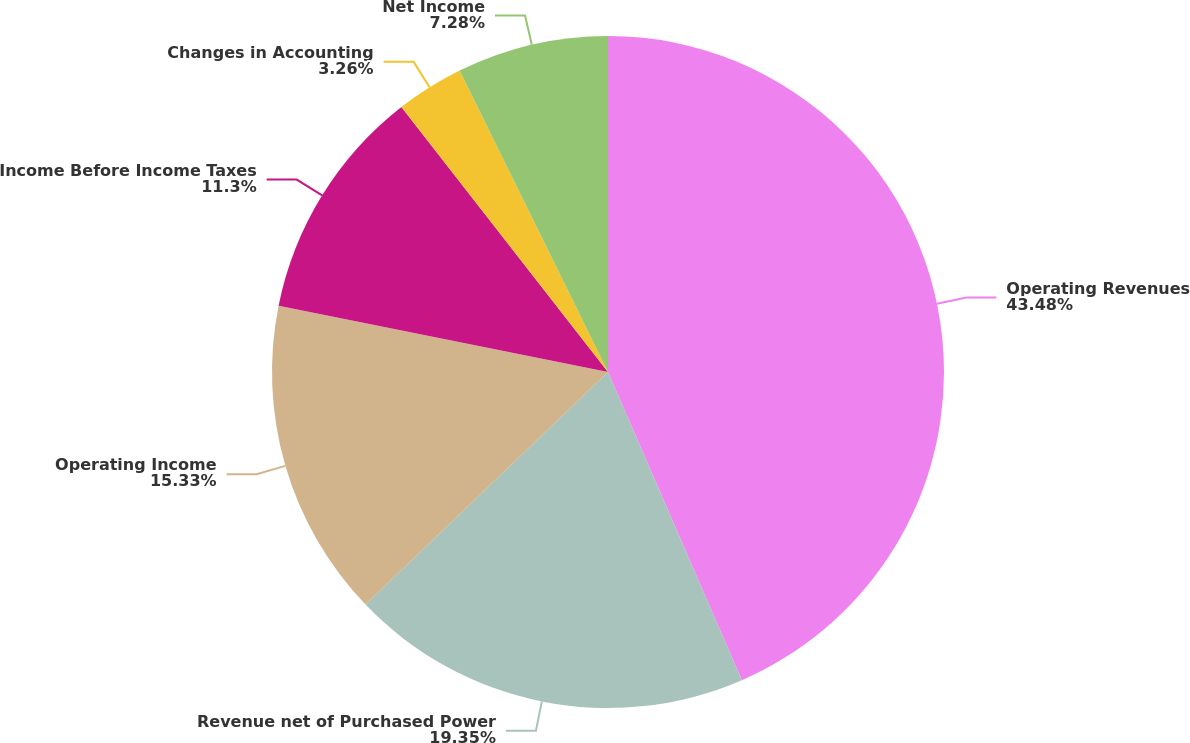<chart> <loc_0><loc_0><loc_500><loc_500><pie_chart><fcel>Operating Revenues<fcel>Revenue net of Purchased Power<fcel>Operating Income<fcel>Income Before Income Taxes<fcel>Changes in Accounting<fcel>Net Income<nl><fcel>43.48%<fcel>19.35%<fcel>15.33%<fcel>11.3%<fcel>3.26%<fcel>7.28%<nl></chart> 